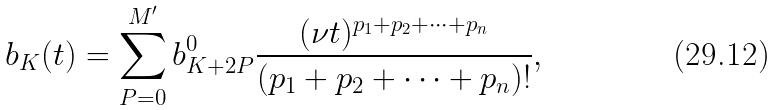Convert formula to latex. <formula><loc_0><loc_0><loc_500><loc_500>b _ { K } ( t ) = \sum _ { P = 0 } ^ { M ^ { \prime } } b _ { K + 2 P } ^ { 0 } \frac { ( \nu t ) ^ { p _ { 1 } + p _ { 2 } + \dots + p _ { n } } } { ( p _ { 1 } + p _ { 2 } + \dots + p _ { n } ) ! } ,</formula> 